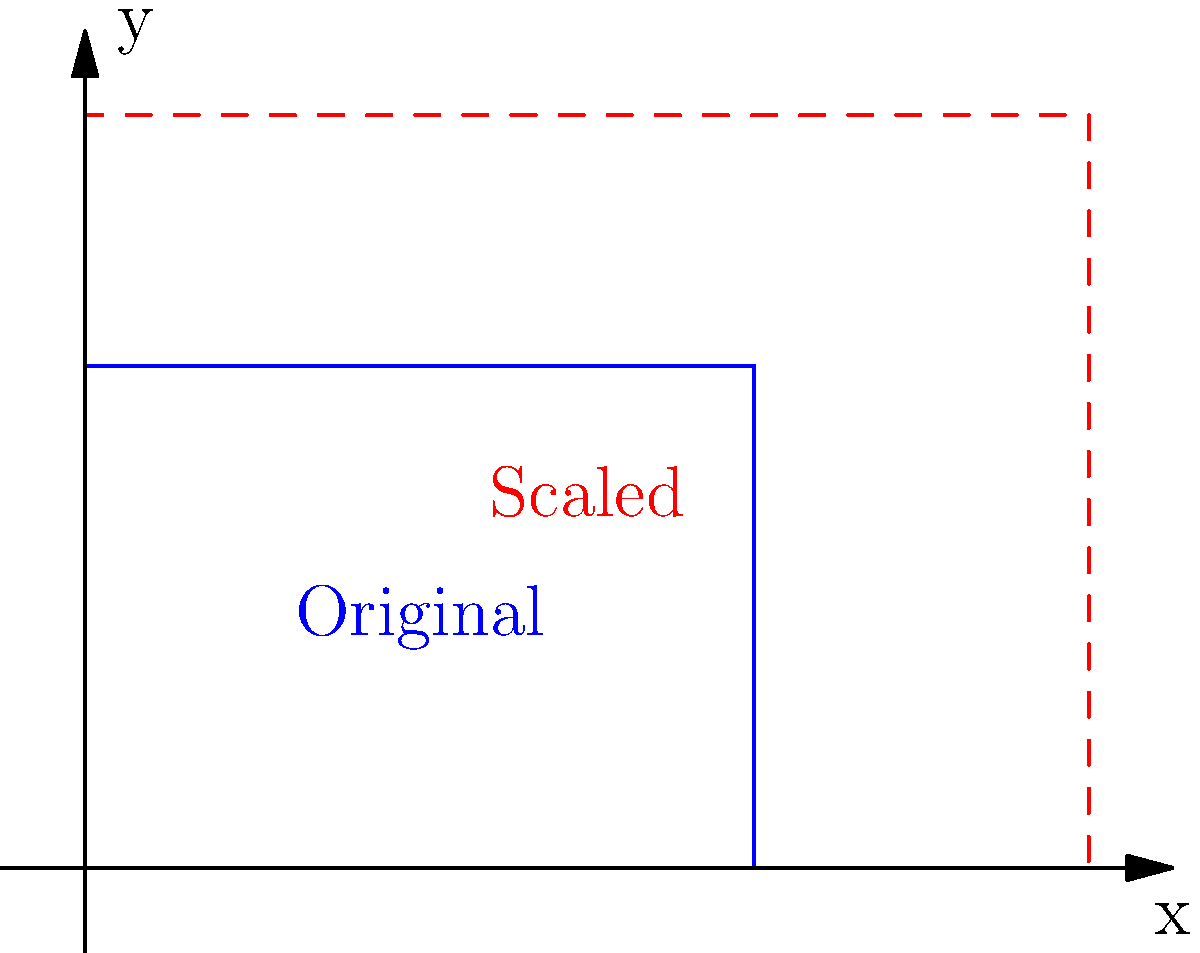In "The Republic of Sarah," the town of Greylock needs to expand its layout to accommodate population growth while maintaining its original shape. The current rectangular town layout measures 4 units wide and 3 units tall. If the town needs to increase its area by 125% to meet the growing population's needs, what should be the dimensions of the new scaled layout? Let's approach this step-by-step:

1) First, let's calculate the current area of the town:
   Area = width × height = 4 × 3 = 12 square units

2) The town needs to increase its area by 125%. This means the new area will be:
   New Area = Current Area + 125% of Current Area
   New Area = 12 + (1.25 × 12) = 12 + 15 = 27 square units

3) To maintain the original shape, we need to scale both dimensions by the same factor. Let's call this scale factor $s$.

4) The relationship between the old and new areas can be expressed as:
   New Area = $s^2$ × Old Area
   27 = $s^2$ × 12

5) Solving for $s$:
   $s^2 = 27 ÷ 12 = 2.25$
   $s = \sqrt{2.25} = 1.5$

6) Now we can calculate the new dimensions:
   New width = 4 × 1.5 = 6 units
   New height = 3 × 1.5 = 4.5 units

Therefore, the new dimensions of the scaled layout should be 6 units wide and 4.5 units tall.
Answer: 6 units × 4.5 units 